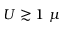Convert formula to latex. <formula><loc_0><loc_0><loc_500><loc_500>U \gtrsim 1 \ \mu</formula> 